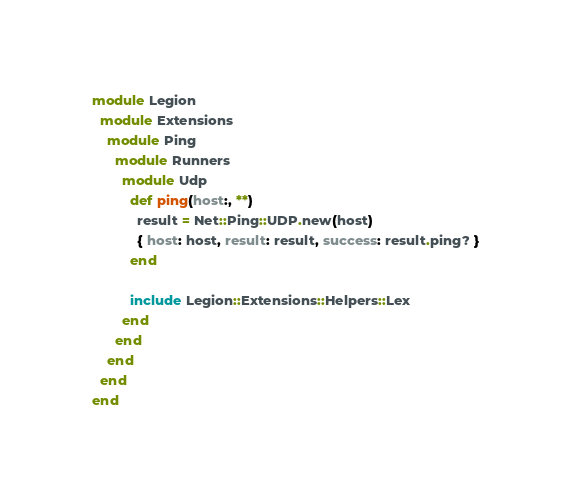<code> <loc_0><loc_0><loc_500><loc_500><_Ruby_>module Legion
  module Extensions
    module Ping
      module Runners
        module Udp
          def ping(host:, **)
            result = Net::Ping::UDP.new(host)
            { host: host, result: result, success: result.ping? }
          end

          include Legion::Extensions::Helpers::Lex
        end
      end
    end
  end
end
</code> 